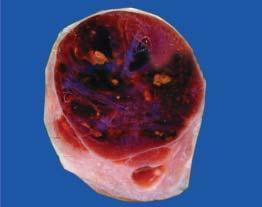s the thyroid gland enlarged diffusely?
Answer the question using a single word or phrase. Yes 